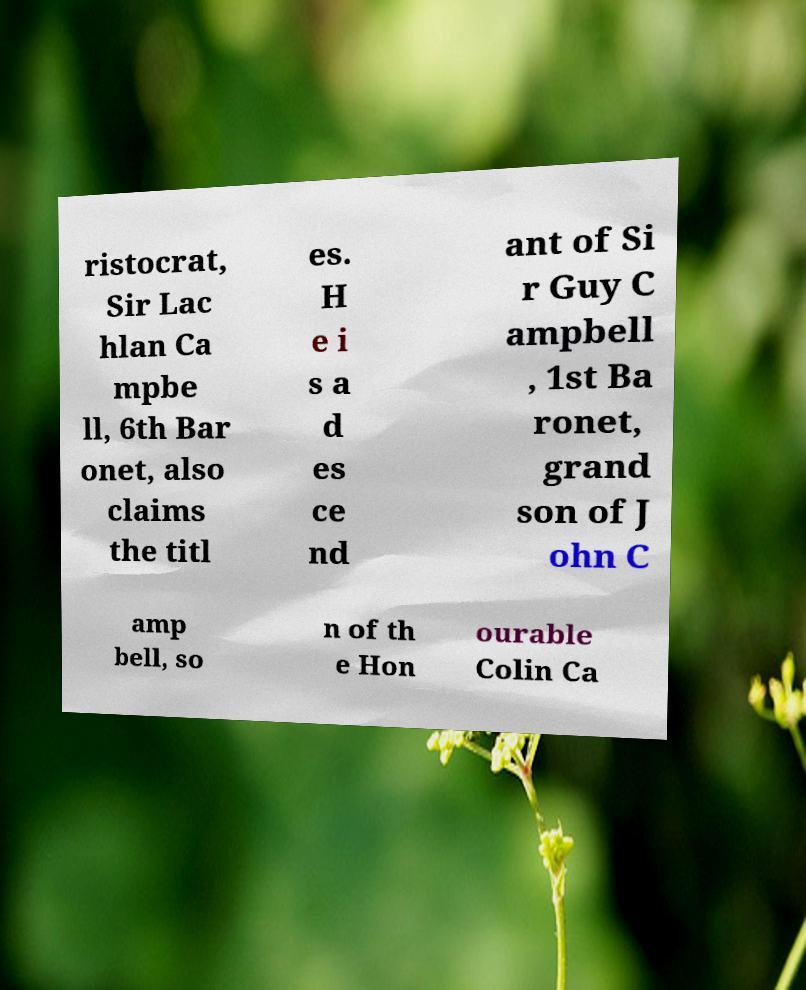For documentation purposes, I need the text within this image transcribed. Could you provide that? ristocrat, Sir Lac hlan Ca mpbe ll, 6th Bar onet, also claims the titl es. H e i s a d es ce nd ant of Si r Guy C ampbell , 1st Ba ronet, grand son of J ohn C amp bell, so n of th e Hon ourable Colin Ca 